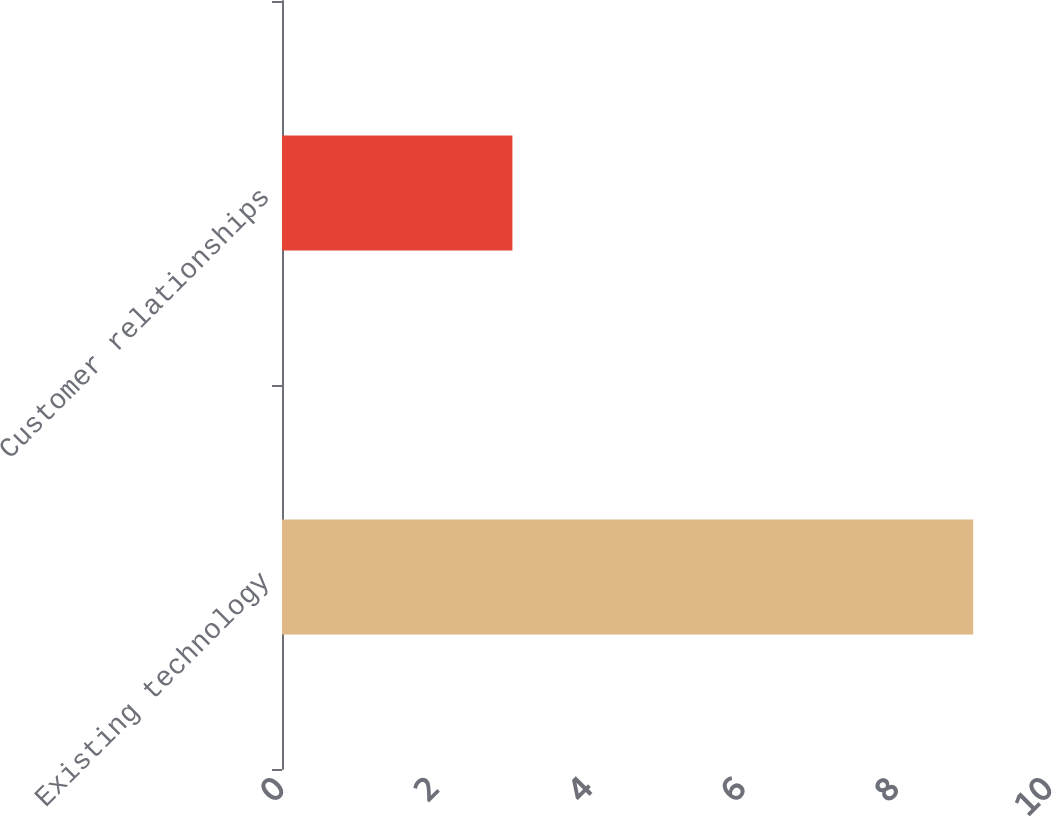Convert chart. <chart><loc_0><loc_0><loc_500><loc_500><bar_chart><fcel>Existing technology<fcel>Customer relationships<nl><fcel>9<fcel>3<nl></chart> 